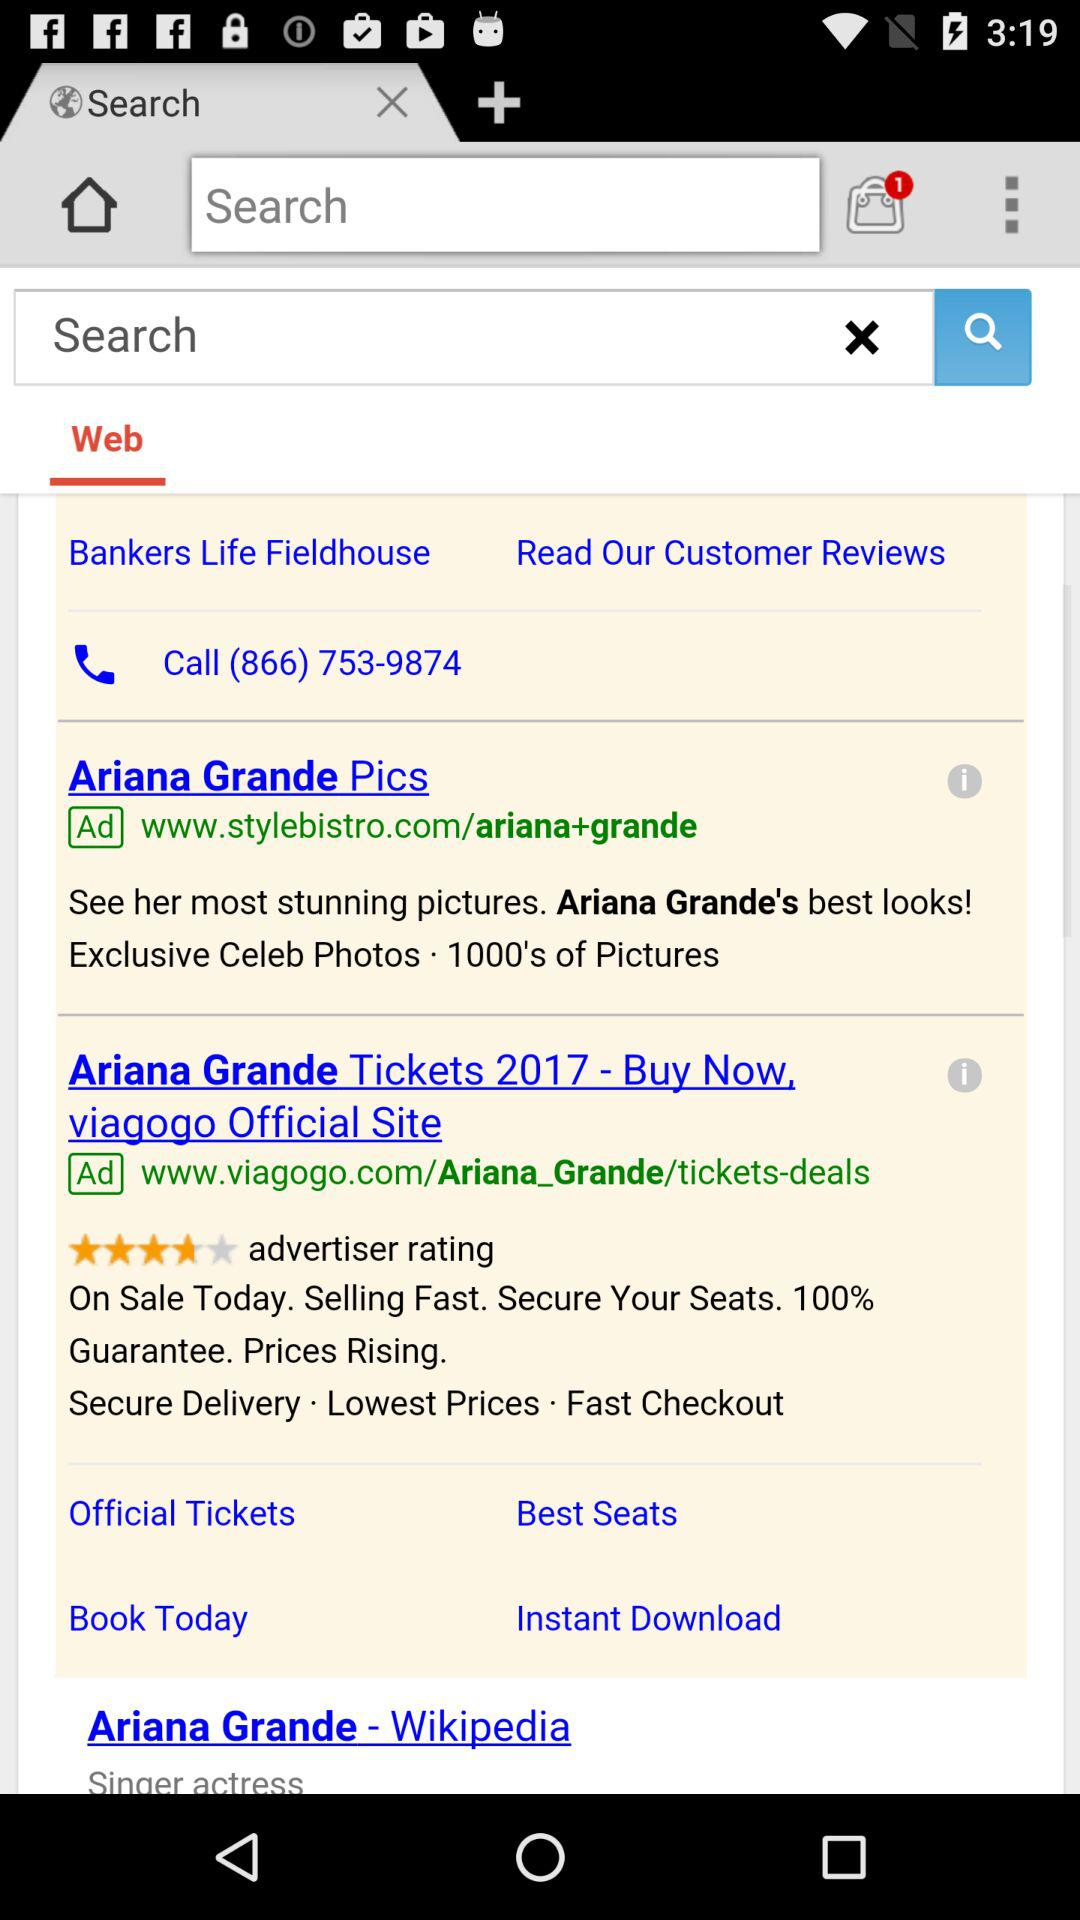What is the contact number? The contact number is (866) 753-9874. 